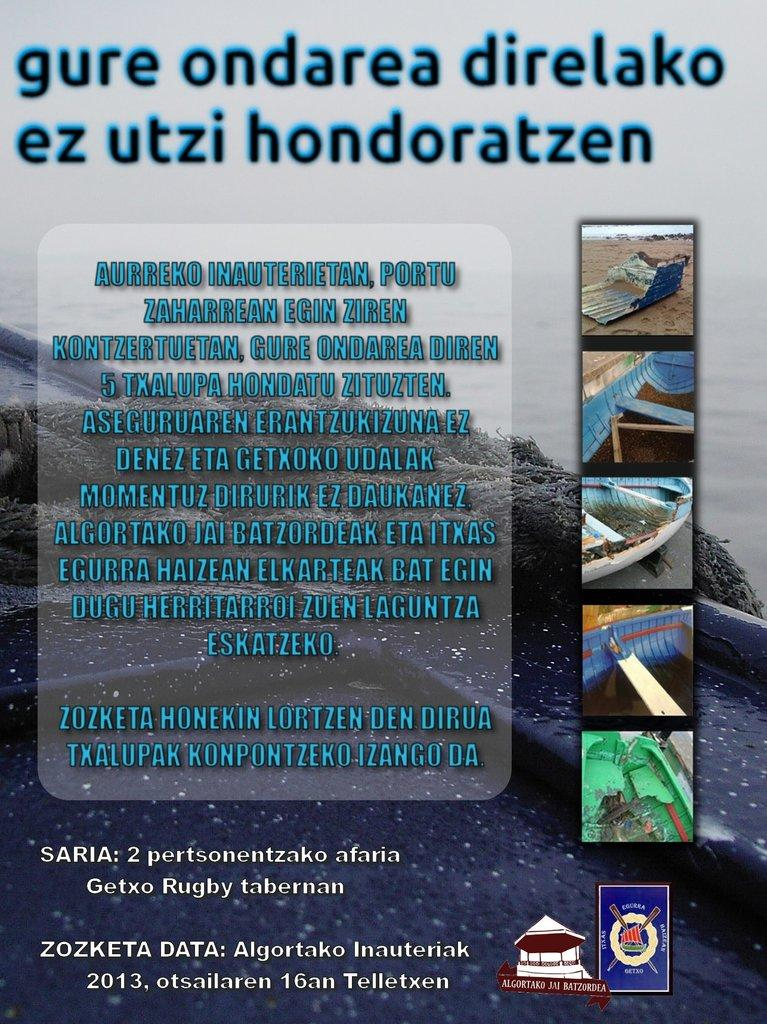<image>
Give a short and clear explanation of the subsequent image. a poster in a foreign language mentioning 2013 at the bottom 